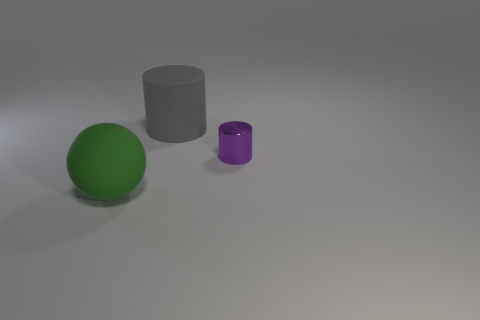Can you describe the lighting and shadows in the scene? The lighting in the scene seems to come from a high angle, which indicates that there might be a single bright light source positioned above the objects. It casts soft shadows on the ground. The shadows are more pronounced directly under the objects, suggesting that the light is not directly overhead but slightly to the side. The sphere and the cylinders have shadows that are diffuse at the edges, which hints at a slightly overcast quality to the light. 